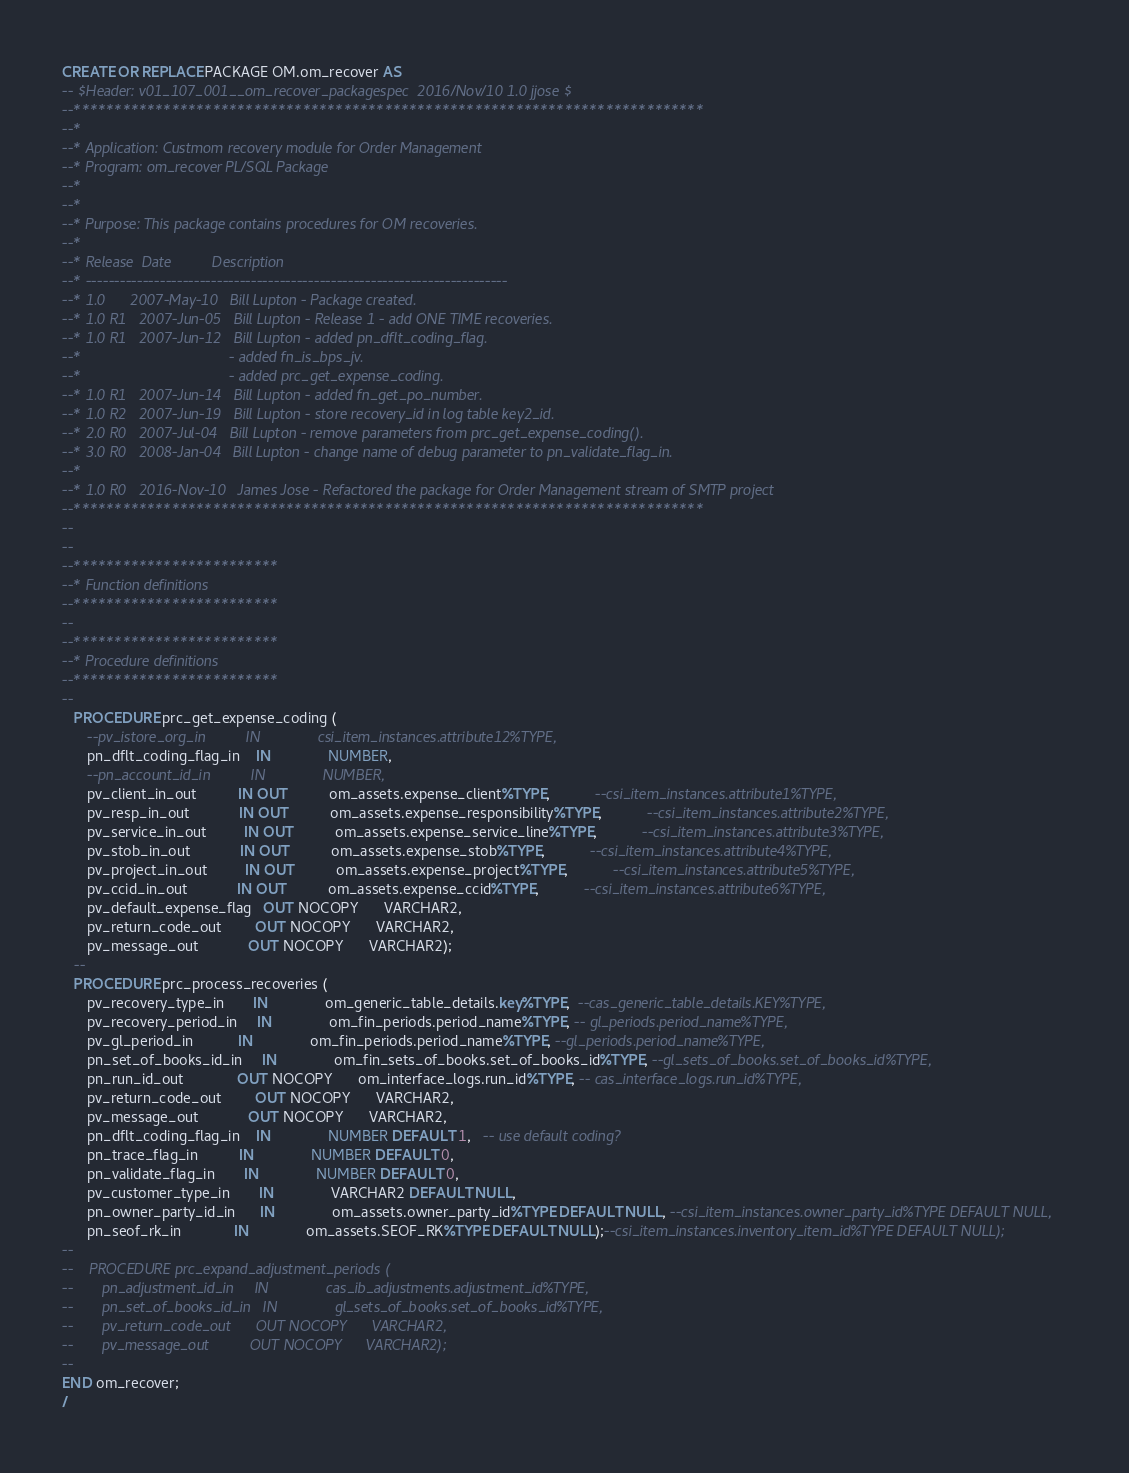Convert code to text. <code><loc_0><loc_0><loc_500><loc_500><_SQL_>
CREATE OR REPLACE PACKAGE OM.om_recover AS
-- $Header: v01_107_001__om_recover_packagespec  2016/Nov/10 1.0 jjose $
--*****************************************************************************
--*
--* Application: Custmom recovery module for Order Management
--* Program: om_recover PL/SQL Package
--*
--* 
--* Purpose: This package contains procedures for OM recoveries.
--*
--* Release  Date          Description
--* --------------------------------------------------------------------------
--* 1.0      2007-May-10   Bill Lupton - Package created.
--* 1.0 R1   2007-Jun-05   Bill Lupton - Release 1 - add ONE TIME recoveries.
--* 1.0 R1   2007-Jun-12   Bill Lupton - added pn_dflt_coding_flag.
--*                                    - added fn_is_bps_jv.
--*                                    - added prc_get_expense_coding.
--* 1.0 R1   2007-Jun-14   Bill Lupton - added fn_get_po_number.
--* 1.0 R2   2007-Jun-19   Bill Lupton - store recovery_id in log table key2_id.
--* 2.0 R0   2007-Jul-04   Bill Lupton - remove parameters from prc_get_expense_coding().
--* 3.0 R0   2008-Jan-04   Bill Lupton - change name of debug parameter to pn_validate_flag_in.
--*
--* 1.0 R0   2016-Nov-10   James Jose - Refactored the package for Order Management stream of SMTP project
--*****************************************************************************
--
--
--*************************
--* Function definitions
--*************************
--
--*************************
--* Procedure definitions
--*************************
--
   PROCEDURE prc_get_expense_coding (
      --pv_istore_org_in          IN              csi_item_instances.attribute12%TYPE,
      pn_dflt_coding_flag_in    IN              NUMBER,
      --pn_account_id_in          IN              NUMBER,
      pv_client_in_out          IN OUT          om_assets.expense_client%TYPE,           --csi_item_instances.attribute1%TYPE,
      pv_resp_in_out            IN OUT          om_assets.expense_responsibility%TYPE,           --csi_item_instances.attribute2%TYPE,
      pv_service_in_out         IN OUT          om_assets.expense_service_line%TYPE,           --csi_item_instances.attribute3%TYPE,
      pv_stob_in_out            IN OUT          om_assets.expense_stob%TYPE,           --csi_item_instances.attribute4%TYPE,
      pv_project_in_out         IN OUT          om_assets.expense_project%TYPE,           --csi_item_instances.attribute5%TYPE,
      pv_ccid_in_out            IN OUT          om_assets.expense_ccid%TYPE,           --csi_item_instances.attribute6%TYPE,
      pv_default_expense_flag   OUT NOCOPY      VARCHAR2,
      pv_return_code_out        OUT NOCOPY      VARCHAR2,
      pv_message_out            OUT NOCOPY      VARCHAR2);
   --
   PROCEDURE prc_process_recoveries (
      pv_recovery_type_in       IN              om_generic_table_details.key%TYPE,  --cas_generic_table_details.KEY%TYPE,
      pv_recovery_period_in     IN              om_fin_periods.period_name%TYPE, -- gl_periods.period_name%TYPE,
      pv_gl_period_in           IN              om_fin_periods.period_name%TYPE, --gl_periods.period_name%TYPE,
      pn_set_of_books_id_in     IN              om_fin_sets_of_books.set_of_books_id%TYPE, --gl_sets_of_books.set_of_books_id%TYPE,
      pn_run_id_out             OUT NOCOPY      om_interface_logs.run_id%TYPE, -- cas_interface_logs.run_id%TYPE,
      pv_return_code_out        OUT NOCOPY      VARCHAR2,
      pv_message_out            OUT NOCOPY      VARCHAR2,
      pn_dflt_coding_flag_in    IN              NUMBER DEFAULT 1,   -- use default coding?
      pn_trace_flag_in          IN              NUMBER DEFAULT 0,
      pn_validate_flag_in       IN              NUMBER DEFAULT 0,
      pv_customer_type_in       IN              VARCHAR2 DEFAULT NULL,
      pn_owner_party_id_in      IN              om_assets.owner_party_id%TYPE DEFAULT NULL, --csi_item_instances.owner_party_id%TYPE DEFAULT NULL,
      pn_seof_rk_in             IN              om_assets.SEOF_RK%TYPE DEFAULT NULL);--csi_item_instances.inventory_item_id%TYPE DEFAULT NULL);
--
--    PROCEDURE prc_expand_adjustment_periods (
--       pn_adjustment_id_in     IN              cas_ib_adjustments.adjustment_id%TYPE,
--       pn_set_of_books_id_in   IN              gl_sets_of_books.set_of_books_id%TYPE,
--       pv_return_code_out      OUT NOCOPY      VARCHAR2,
--       pv_message_out          OUT NOCOPY      VARCHAR2);
--
END om_recover;
/
</code> 